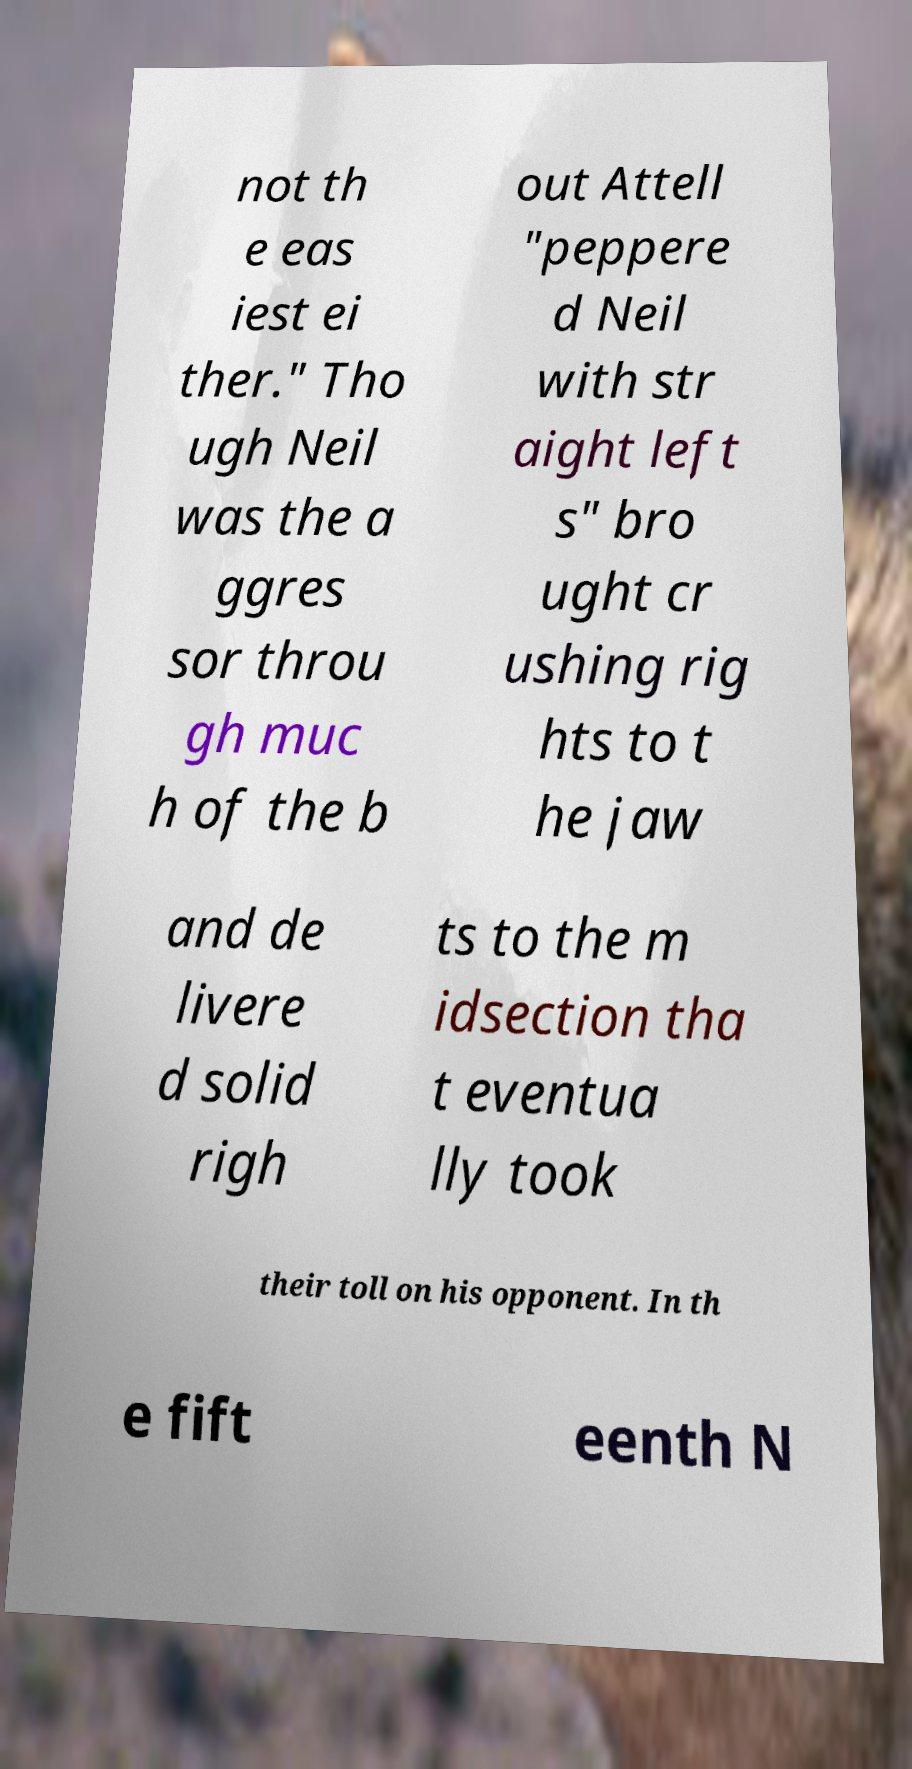For documentation purposes, I need the text within this image transcribed. Could you provide that? not th e eas iest ei ther." Tho ugh Neil was the a ggres sor throu gh muc h of the b out Attell "peppere d Neil with str aight left s" bro ught cr ushing rig hts to t he jaw and de livere d solid righ ts to the m idsection tha t eventua lly took their toll on his opponent. In th e fift eenth N 